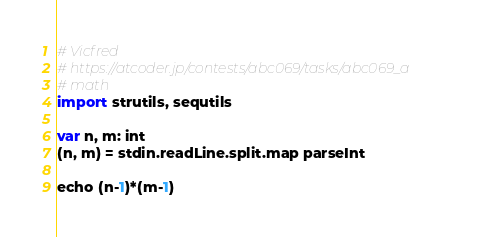Convert code to text. <code><loc_0><loc_0><loc_500><loc_500><_Nim_># Vicfred
# https://atcoder.jp/contests/abc069/tasks/abc069_a
# math
import strutils, sequtils

var n, m: int
(n, m) = stdin.readLine.split.map parseInt

echo (n-1)*(m-1)
</code> 